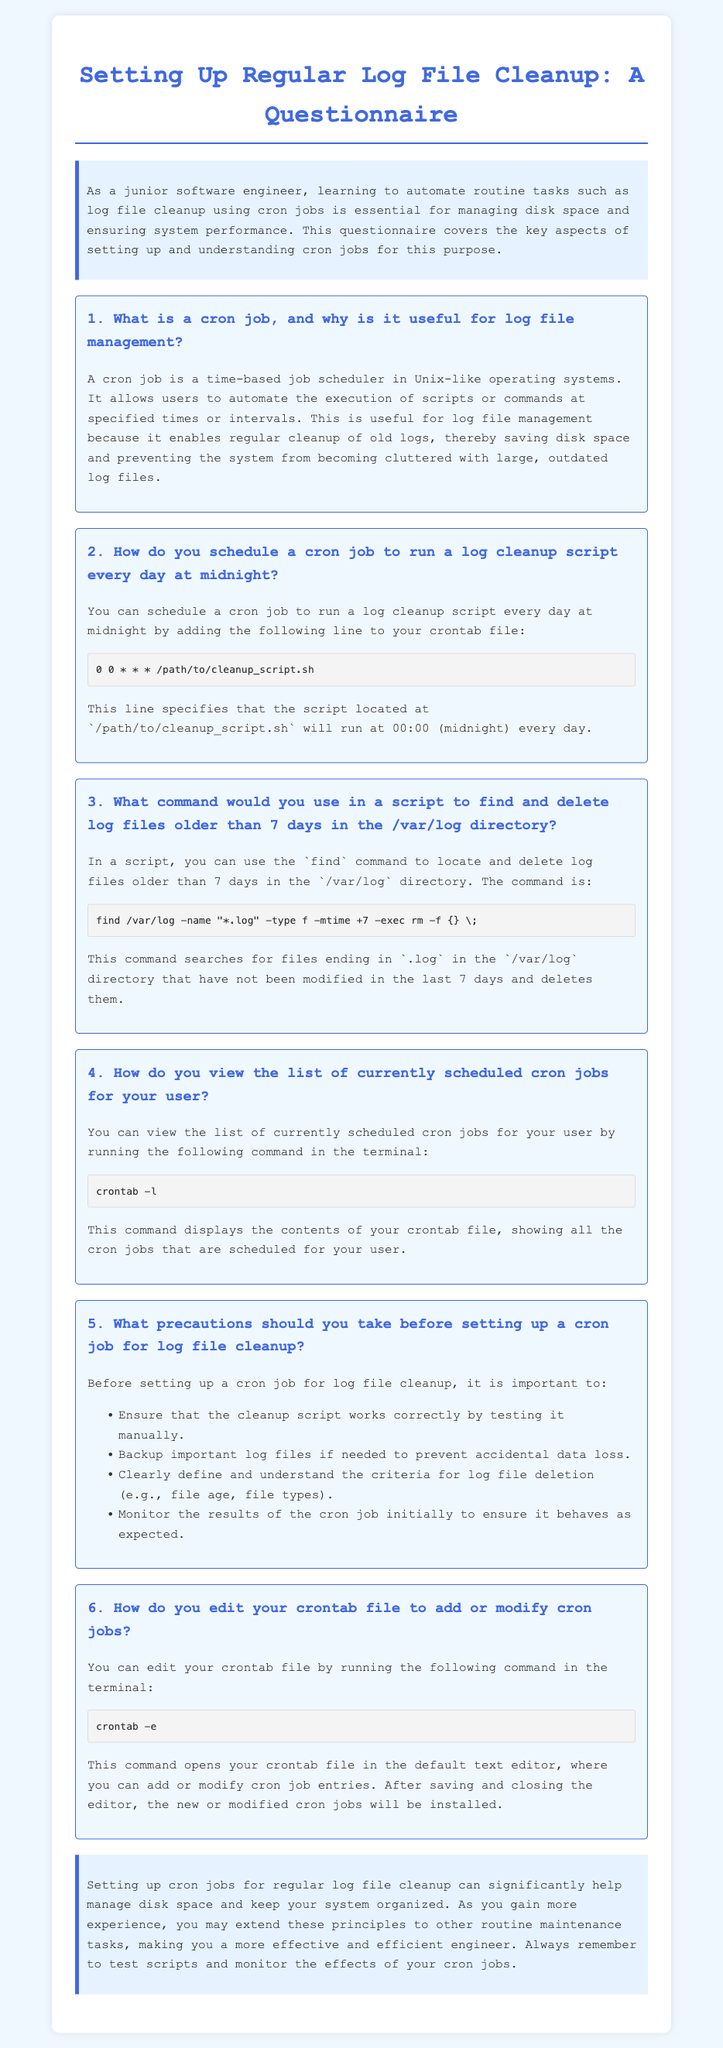What is a cron job? A cron job is a time-based job scheduler in Unix-like operating systems that automates the execution of scripts or commands at specified times or intervals.
Answer: Time-based job scheduler How frequently can you schedule a cron job? The document does not explicitly state a frequency, but it illustrates that cron jobs can be scheduled at specified times or intervals.
Answer: Specified times or intervals What time is the log cleanup script scheduled to run? The document specifies that the log cleanup script is scheduled to run at midnight, which is represented as 00:00.
Answer: Midnight Which command is used to delete log files older than 7 days? The command mentioned in the document for deleting log files older than 7 days is "find /var/log -name "*.log" -type f -mtime +7 -exec rm -f {} \;".
Answer: find /var/log -name "*.log" -type f -mtime +7 -exec rm -f {} \; What precautions should you take before setting up a cron job? The document lists precautions such as testing the cleanup script, backing up important log files, understanding deletion criteria, and monitoring results.
Answer: Testing, backing up, understanding criteria, monitoring How do you open the crontab file for editing? You open the crontab file for editing by running the command "crontab -e".
Answer: crontab -e What is the focus of the introduction in the document? The introduction discusses the importance of automating tasks like log file cleanup using cron jobs for managing disk space and ensuring system performance.
Answer: Importance of automation How will the new or modified cron jobs be installed after editing? After saving and closing the editor, the new or modified cron jobs will be installed in the crontab file.
Answer: After saving and closing the editor What color is used for the title? The document indicates that the color used for the title is royal blue.
Answer: Royal blue 